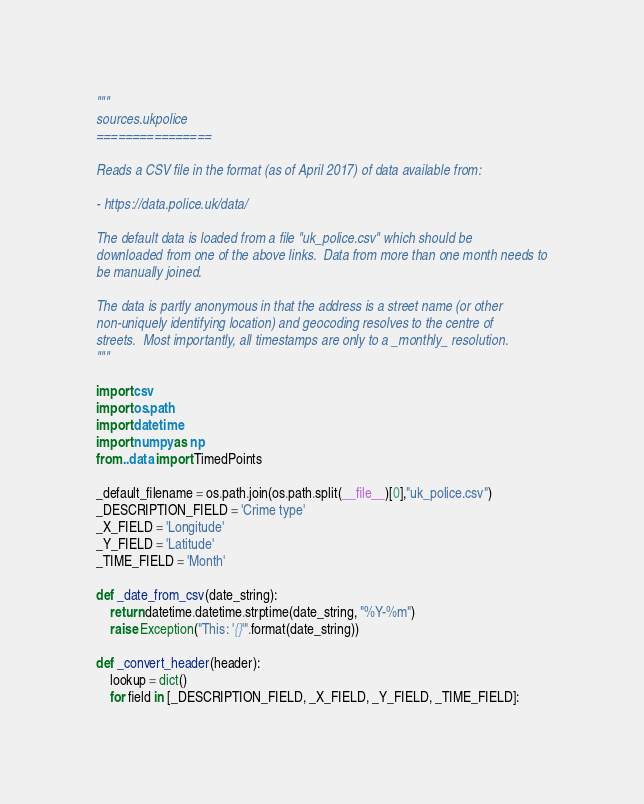Convert code to text. <code><loc_0><loc_0><loc_500><loc_500><_Python_>"""
sources.ukpolice
================

Reads a CSV file in the format (as of April 2017) of data available from:

- https://data.police.uk/data/

The default data is loaded from a file "uk_police.csv" which should be
downloaded from one of the above links.  Data from more than one month needs to
be manually joined.

The data is partly anonymous in that the address is a street name (or other
non-uniquely identifying location) and geocoding resolves to the centre of
streets.  Most importantly, all timestamps are only to a _monthly_ resolution.
"""

import csv
import os.path
import datetime
import numpy as np
from ..data import TimedPoints

_default_filename = os.path.join(os.path.split(__file__)[0],"uk_police.csv")
_DESCRIPTION_FIELD = 'Crime type'
_X_FIELD = 'Longitude'
_Y_FIELD = 'Latitude'
_TIME_FIELD = 'Month'

def _date_from_csv(date_string):
    return datetime.datetime.strptime(date_string, "%Y-%m")
    raise Exception("This: '{}'".format(date_string))

def _convert_header(header):
    lookup = dict()
    for field in [_DESCRIPTION_FIELD, _X_FIELD, _Y_FIELD, _TIME_FIELD]:</code> 